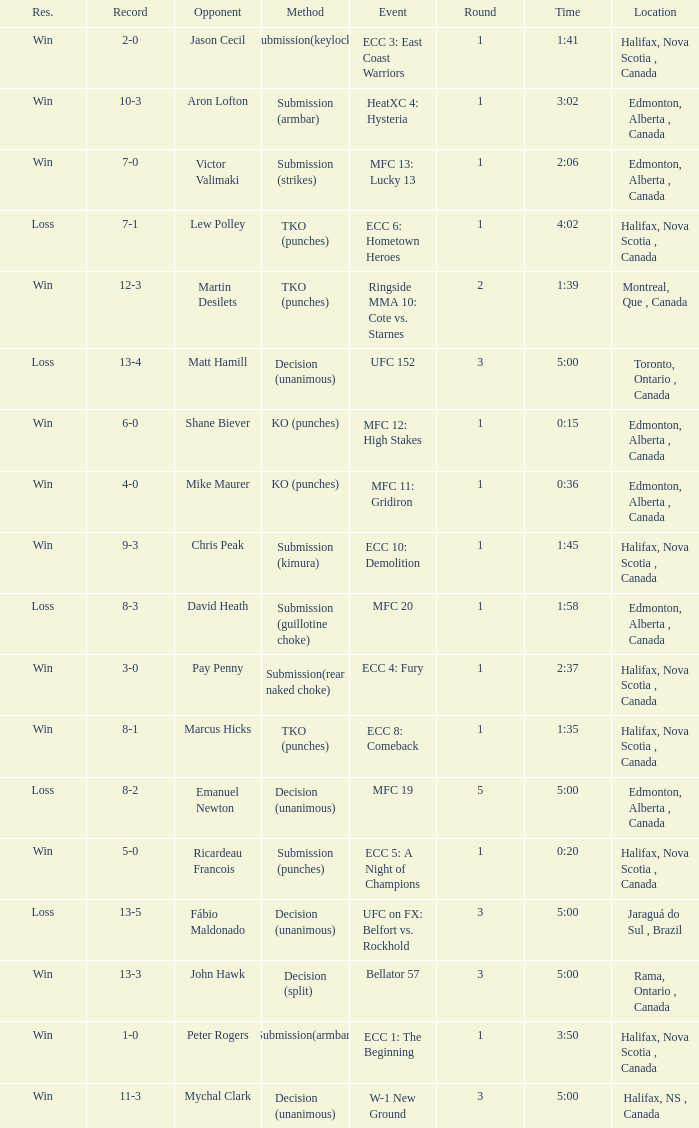What is the location of the match with Aron Lofton as the opponent? Edmonton, Alberta , Canada. 